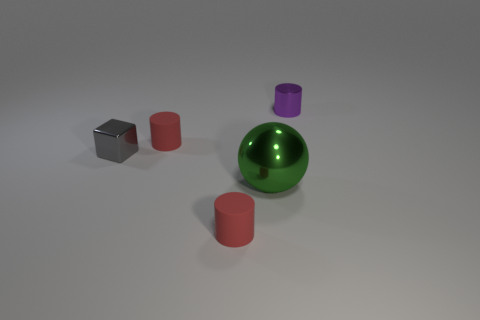How many red cylinders must be subtracted to get 1 red cylinders? 1 Add 3 small purple objects. How many objects exist? 8 Subtract all cubes. How many objects are left? 4 Add 4 small gray shiny blocks. How many small gray shiny blocks are left? 5 Add 2 gray shiny things. How many gray shiny things exist? 3 Subtract 0 red blocks. How many objects are left? 5 Subtract all large green shiny objects. Subtract all purple metallic cylinders. How many objects are left? 3 